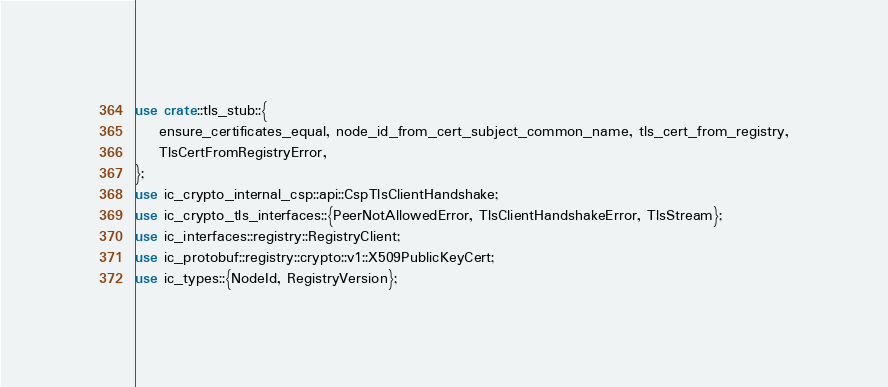<code> <loc_0><loc_0><loc_500><loc_500><_Rust_>use crate::tls_stub::{
    ensure_certificates_equal, node_id_from_cert_subject_common_name, tls_cert_from_registry,
    TlsCertFromRegistryError,
};
use ic_crypto_internal_csp::api::CspTlsClientHandshake;
use ic_crypto_tls_interfaces::{PeerNotAllowedError, TlsClientHandshakeError, TlsStream};
use ic_interfaces::registry::RegistryClient;
use ic_protobuf::registry::crypto::v1::X509PublicKeyCert;
use ic_types::{NodeId, RegistryVersion};</code> 